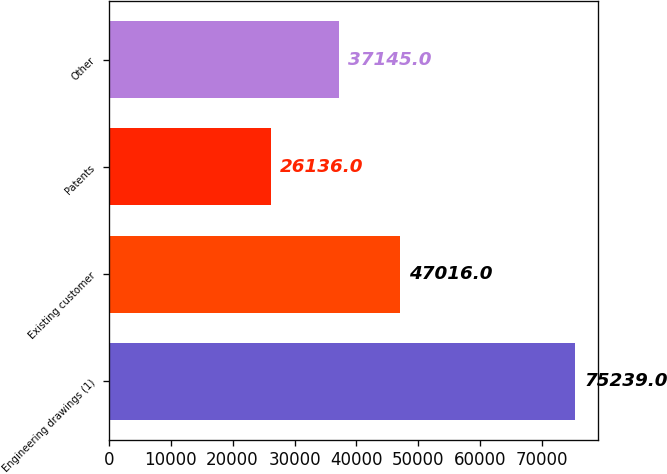<chart> <loc_0><loc_0><loc_500><loc_500><bar_chart><fcel>Engineering drawings (1)<fcel>Existing customer<fcel>Patents<fcel>Other<nl><fcel>75239<fcel>47016<fcel>26136<fcel>37145<nl></chart> 